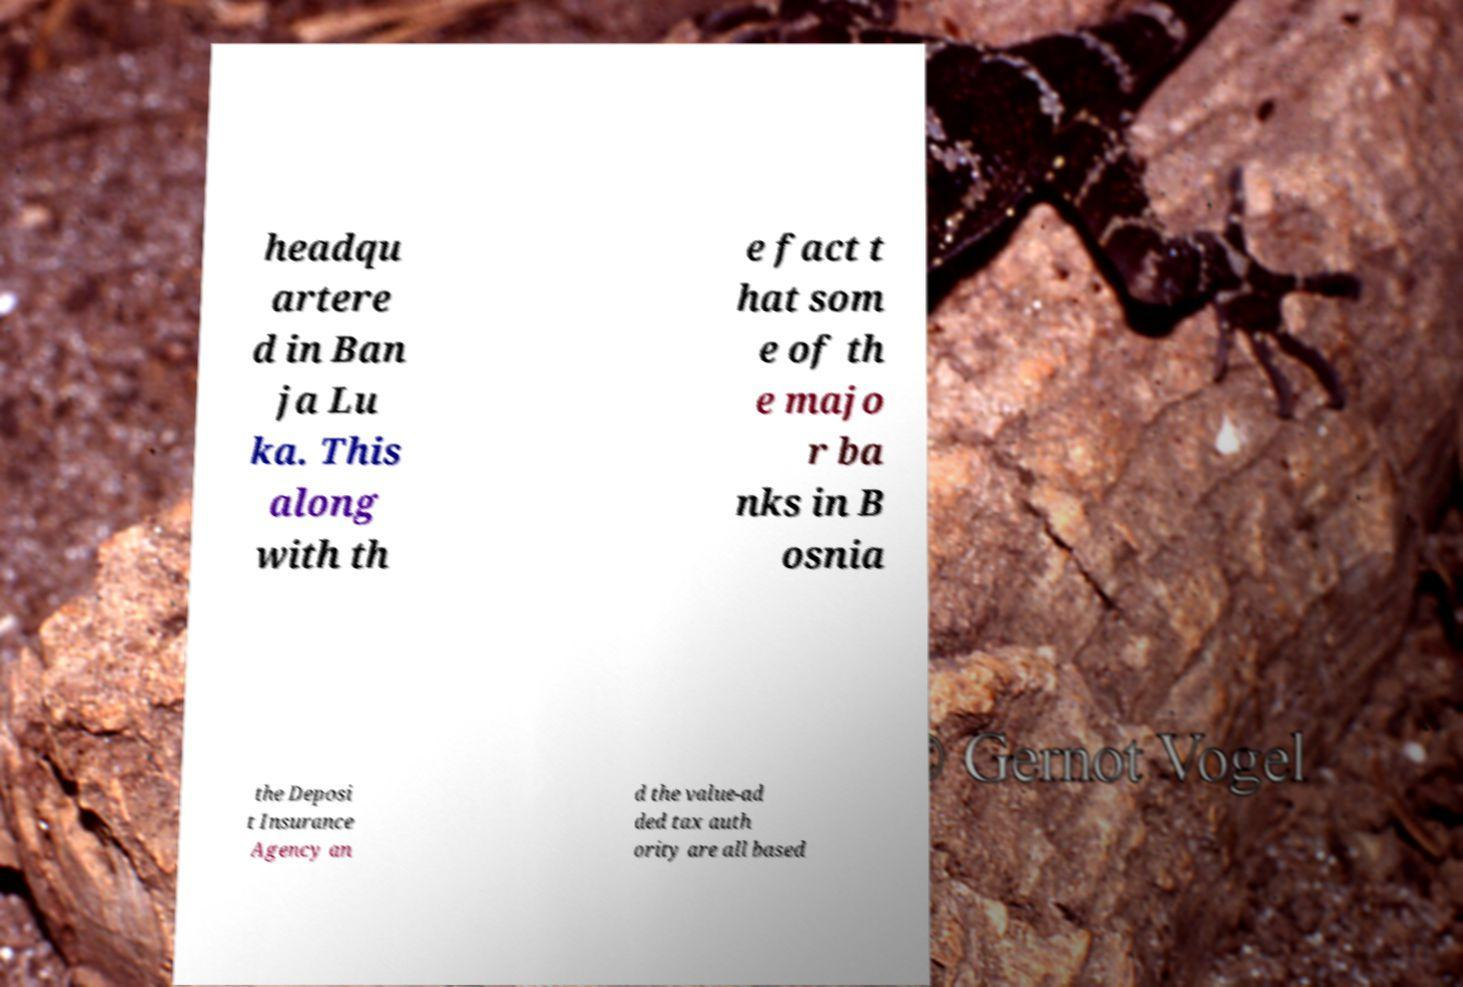I need the written content from this picture converted into text. Can you do that? headqu artere d in Ban ja Lu ka. This along with th e fact t hat som e of th e majo r ba nks in B osnia the Deposi t Insurance Agency an d the value-ad ded tax auth ority are all based 